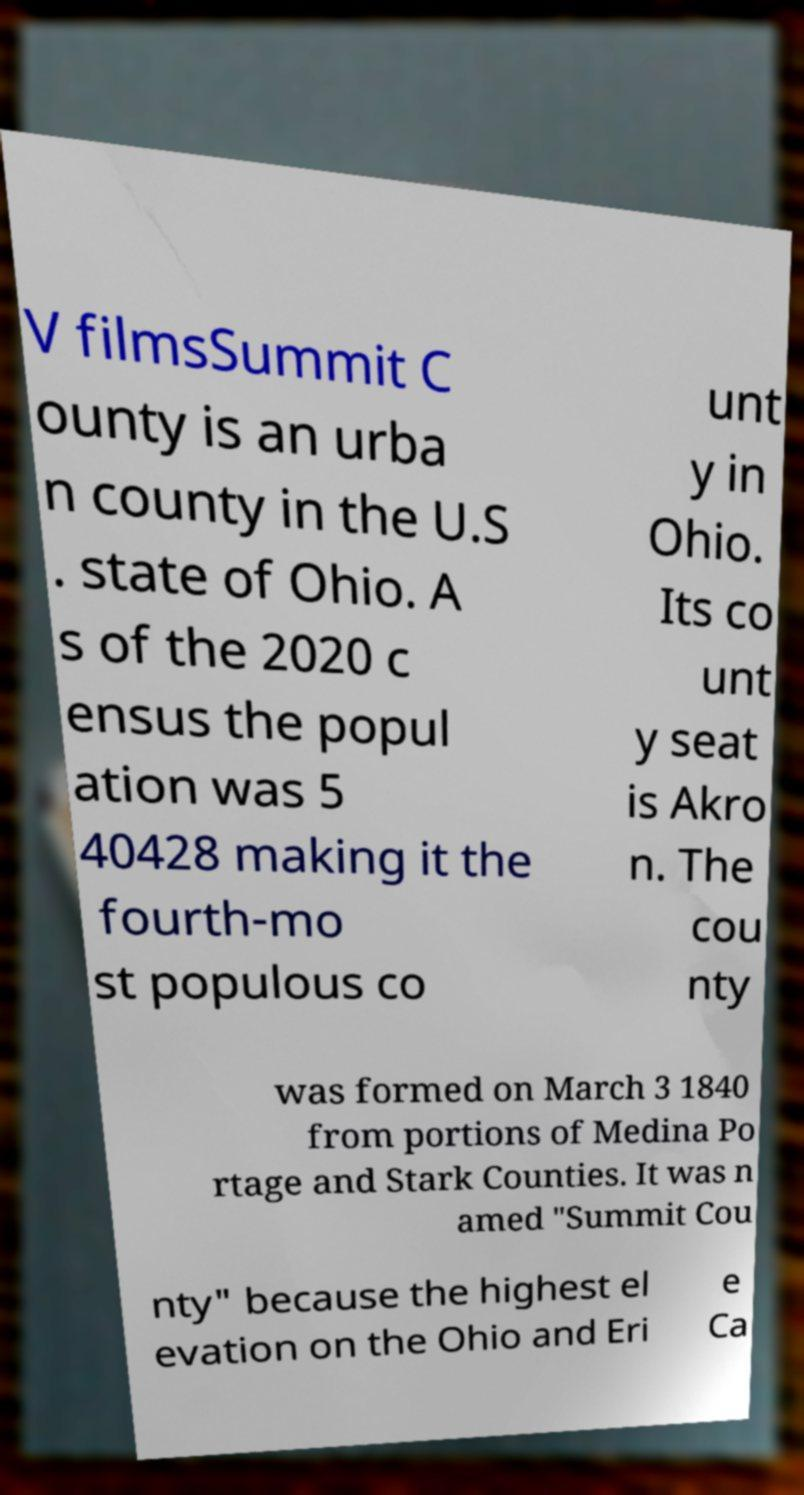There's text embedded in this image that I need extracted. Can you transcribe it verbatim? V filmsSummit C ounty is an urba n county in the U.S . state of Ohio. A s of the 2020 c ensus the popul ation was 5 40428 making it the fourth-mo st populous co unt y in Ohio. Its co unt y seat is Akro n. The cou nty was formed on March 3 1840 from portions of Medina Po rtage and Stark Counties. It was n amed "Summit Cou nty" because the highest el evation on the Ohio and Eri e Ca 